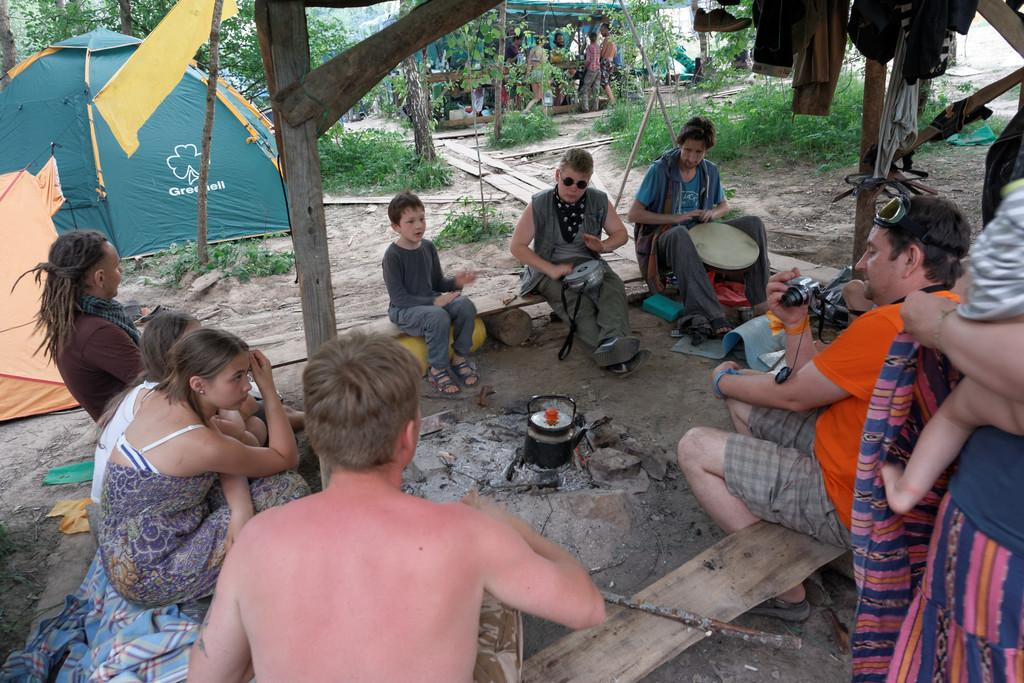How many people are in the image? There is a group of people in the image. What are the people doing in the image? The people are sitting on a bench. What structure can be seen in the image besides the bench? There is a tent in the image. What type of natural environment is visible in the image? There are trees in the image. What type of chair is the camera sitting on in the image? There is no chair or camera present in the image. 